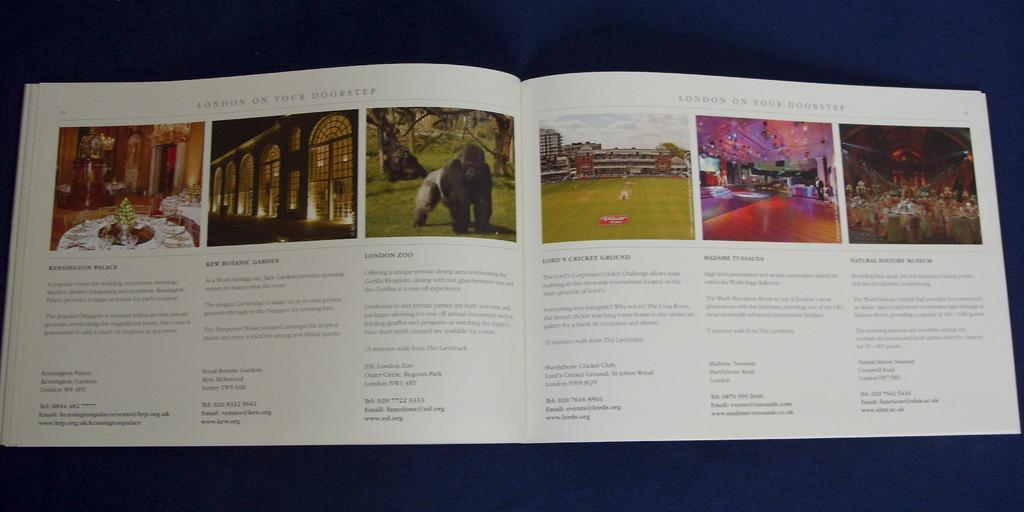<image>
Create a compact narrative representing the image presented. Kensington Palace is seen and described on the page of a book. 